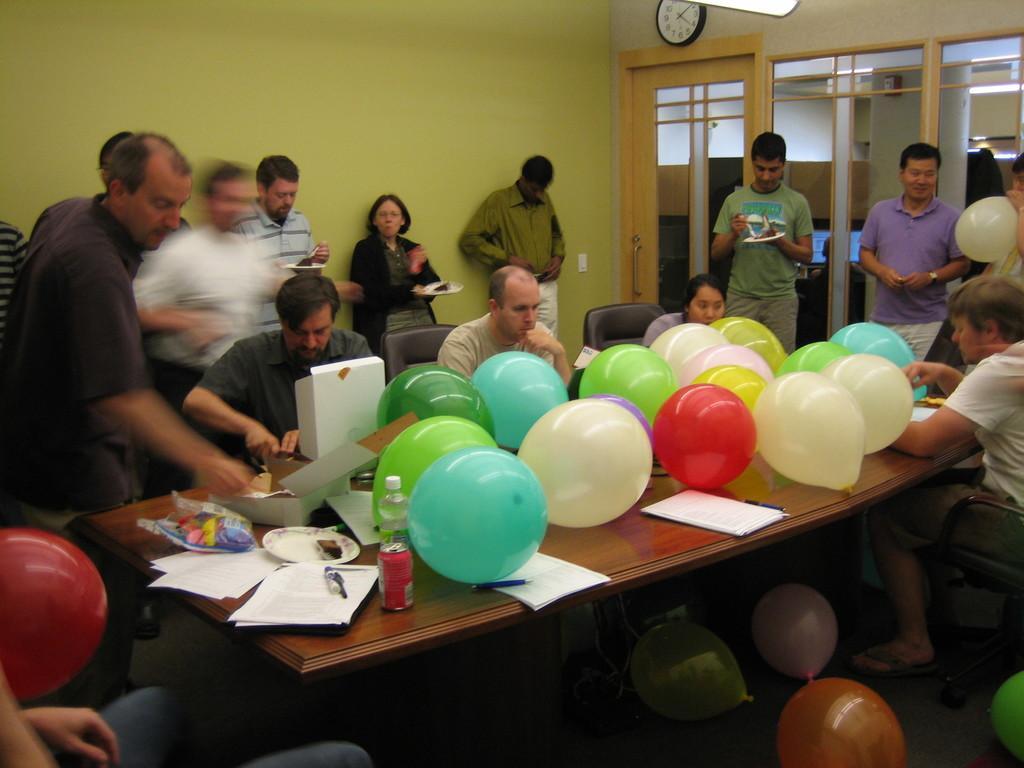Please provide a concise description of this image. In this image I can see number of people were few of them are sitting and rest all are standing. On this table I can see number of balloons and here on this wall I can see a clock. 